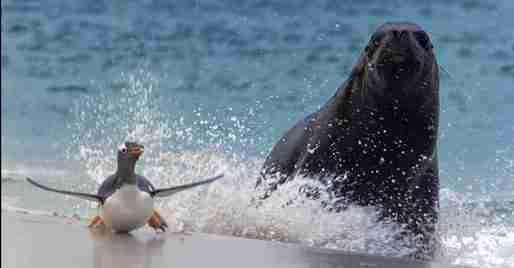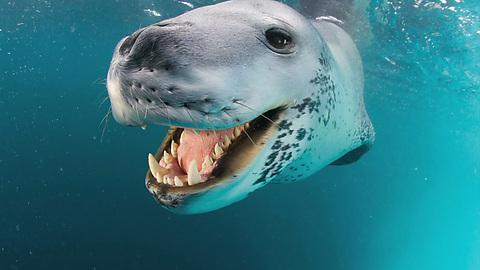The first image is the image on the left, the second image is the image on the right. Analyze the images presented: Is the assertion "One of the images in the pair contains a lone seal without any penguins." valid? Answer yes or no. Yes. The first image is the image on the left, the second image is the image on the right. Examine the images to the left and right. Is the description "a seal with a mouth wide open is trying to catch a penguin" accurate? Answer yes or no. No. 